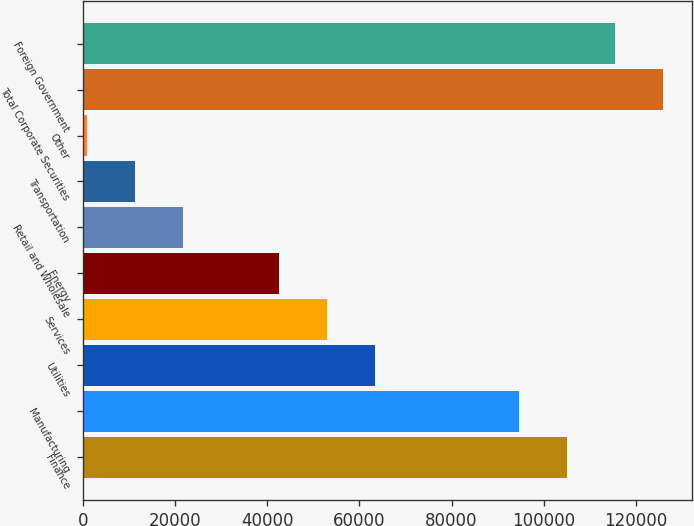Convert chart to OTSL. <chart><loc_0><loc_0><loc_500><loc_500><bar_chart><fcel>Finance<fcel>Manufacturing<fcel>Utilities<fcel>Services<fcel>Energy<fcel>Retail and Wholesale<fcel>Transportation<fcel>Other<fcel>Total Corporate Securities<fcel>Foreign Government<nl><fcel>105012<fcel>94613.7<fcel>63418.8<fcel>53020.5<fcel>42622.2<fcel>21825.6<fcel>11427.3<fcel>1029<fcel>125809<fcel>115410<nl></chart> 